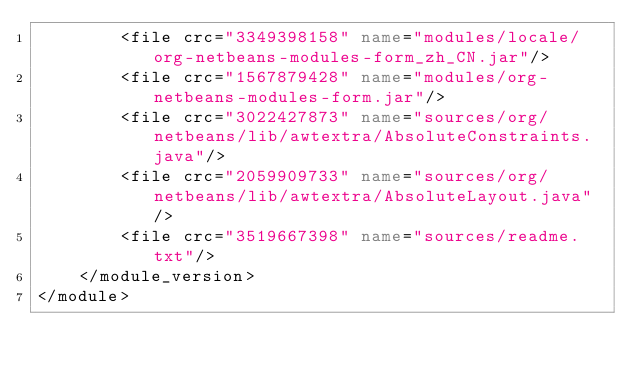<code> <loc_0><loc_0><loc_500><loc_500><_XML_>        <file crc="3349398158" name="modules/locale/org-netbeans-modules-form_zh_CN.jar"/>
        <file crc="1567879428" name="modules/org-netbeans-modules-form.jar"/>
        <file crc="3022427873" name="sources/org/netbeans/lib/awtextra/AbsoluteConstraints.java"/>
        <file crc="2059909733" name="sources/org/netbeans/lib/awtextra/AbsoluteLayout.java"/>
        <file crc="3519667398" name="sources/readme.txt"/>
    </module_version>
</module>
</code> 